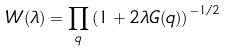<formula> <loc_0><loc_0><loc_500><loc_500>W ( \lambda ) = \prod _ { q } \left ( 1 + 2 \lambda G ( q ) \right ) ^ { - 1 / 2 }</formula> 